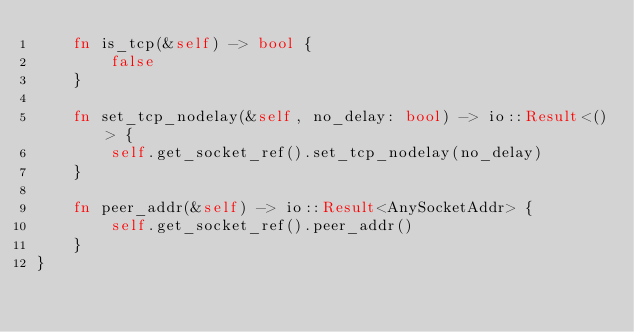<code> <loc_0><loc_0><loc_500><loc_500><_Rust_>    fn is_tcp(&self) -> bool {
        false
    }

    fn set_tcp_nodelay(&self, no_delay: bool) -> io::Result<()> {
        self.get_socket_ref().set_tcp_nodelay(no_delay)
    }

    fn peer_addr(&self) -> io::Result<AnySocketAddr> {
        self.get_socket_ref().peer_addr()
    }
}
</code> 